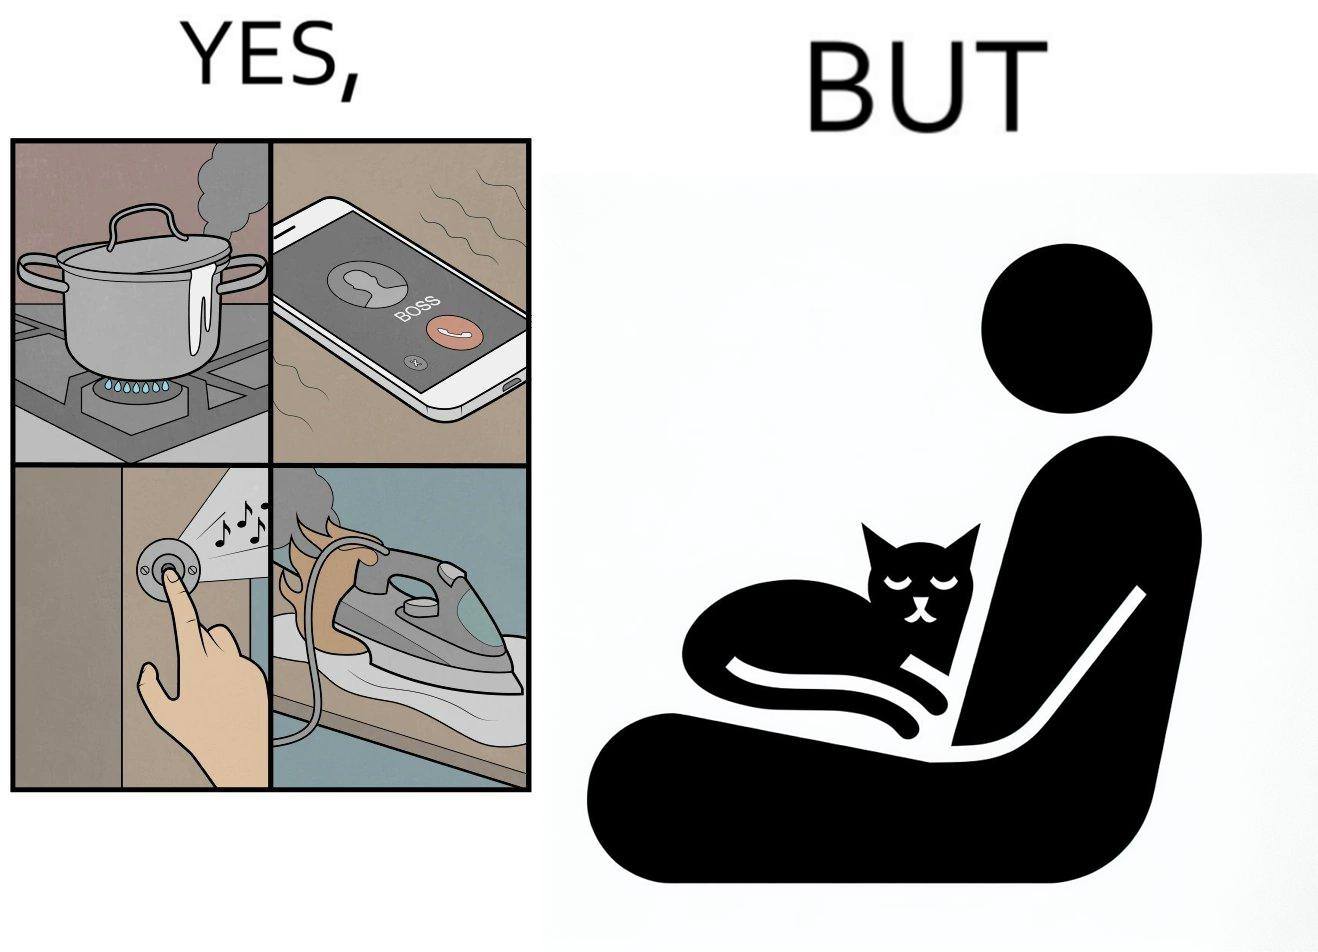Is this image satirical or non-satirical? Yes, this image is satirical. 